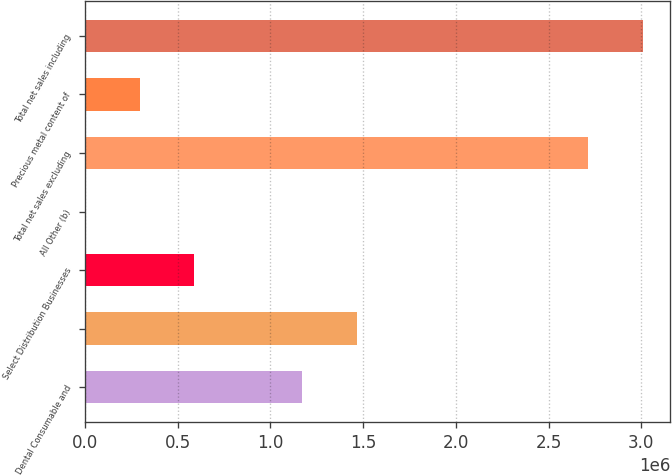Convert chart. <chart><loc_0><loc_0><loc_500><loc_500><bar_chart><fcel>Dental Consumable and<fcel>Unnamed: 1<fcel>Select Distribution Businesses<fcel>All Other (b)<fcel>Total net sales excluding<fcel>Precious metal content of<fcel>Total net sales including<nl><fcel>1.17357e+06<fcel>1.46605e+06<fcel>588623<fcel>3671<fcel>2.7147e+06<fcel>296147<fcel>3.00717e+06<nl></chart> 